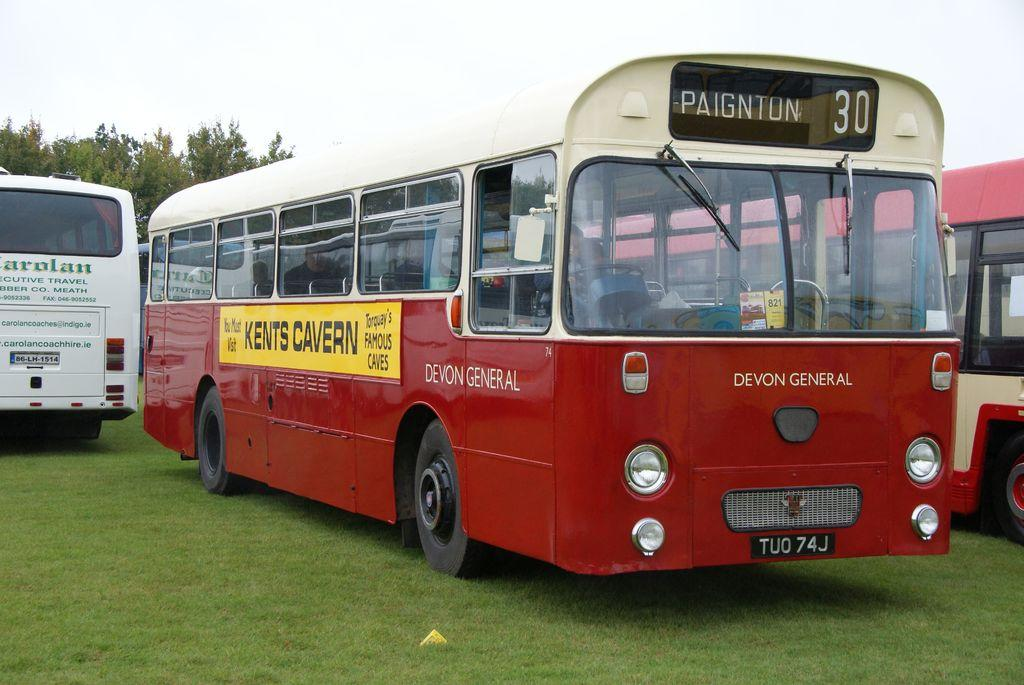What type of vehicles are in the image? There are buses in the image. Where are the buses located? The buses are on the grass. What can be seen in the background of the image? There are trees and the sky visible in the background of the image. How many hands are visible on the buses in the image? There are no hands visible on the buses in the image. What type of beam is supporting the trees in the image? There is no beam present in the image; the trees are standing on their own. 